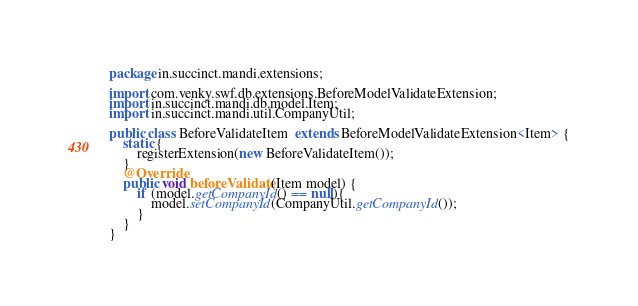Convert code to text. <code><loc_0><loc_0><loc_500><loc_500><_Java_>package in.succinct.mandi.extensions;

import com.venky.swf.db.extensions.BeforeModelValidateExtension;
import in.succinct.mandi.db.model.Item;
import in.succinct.mandi.util.CompanyUtil;

public class BeforeValidateItem  extends BeforeModelValidateExtension<Item> {
    static {
        registerExtension(new BeforeValidateItem());
    }
    @Override
    public void beforeValidate(Item model) {
        if (model.getCompanyId() == null){
            model.setCompanyId(CompanyUtil.getCompanyId());
        }
    }
}
</code> 